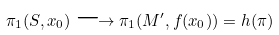Convert formula to latex. <formula><loc_0><loc_0><loc_500><loc_500>\pi _ { 1 } ( S , x _ { 0 } ) \longrightarrow \pi _ { 1 } ( M ^ { \prime } , f ( x _ { 0 } ) ) = h ( \pi )</formula> 